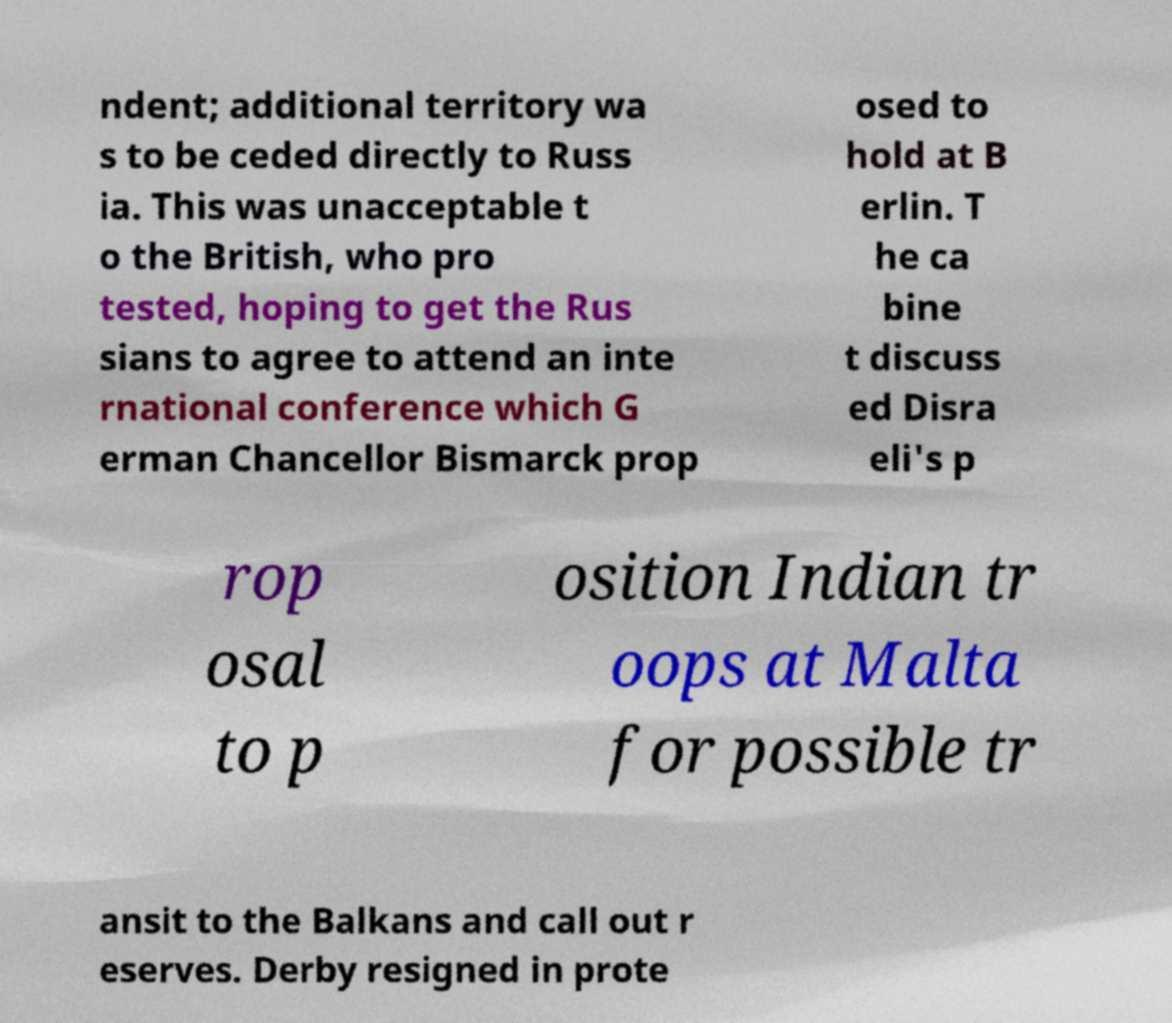Could you assist in decoding the text presented in this image and type it out clearly? ndent; additional territory wa s to be ceded directly to Russ ia. This was unacceptable t o the British, who pro tested, hoping to get the Rus sians to agree to attend an inte rnational conference which G erman Chancellor Bismarck prop osed to hold at B erlin. T he ca bine t discuss ed Disra eli's p rop osal to p osition Indian tr oops at Malta for possible tr ansit to the Balkans and call out r eserves. Derby resigned in prote 